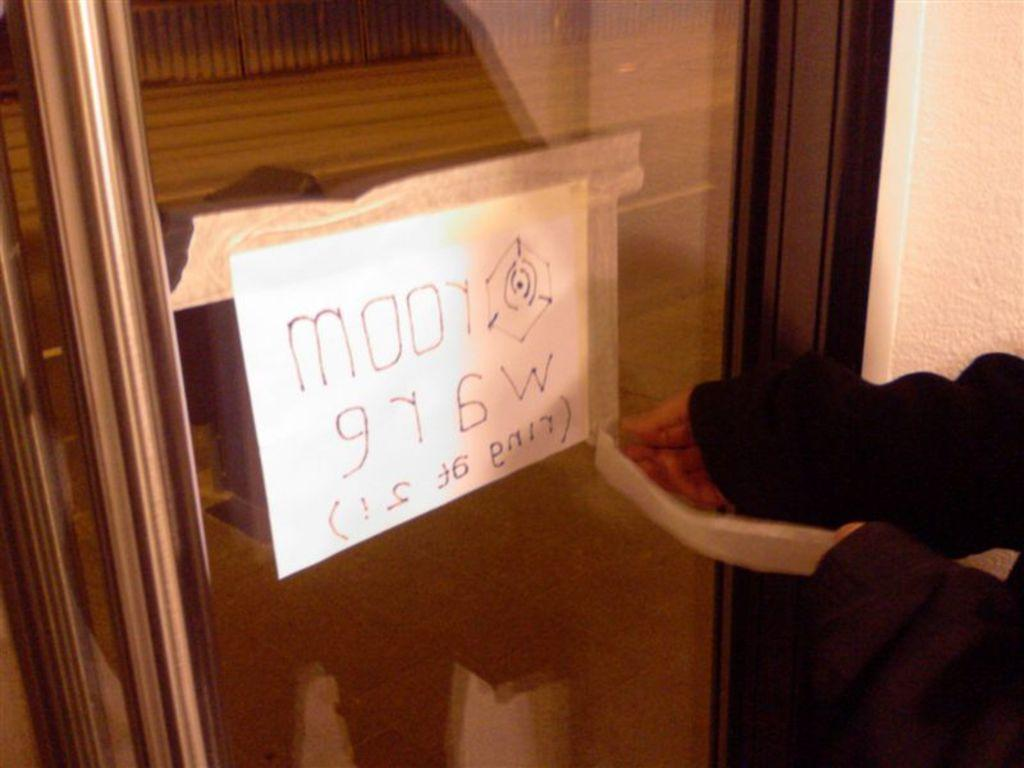What is placed on the door in the image? There is a paper on the door. Can you describe the person in the image? The image contains a person, but no specific details about their appearance or actions are provided. What type of insect is crawling on the person's finger in the image? There is no insect or finger present in the image; it only features a paper on the door and a person. 